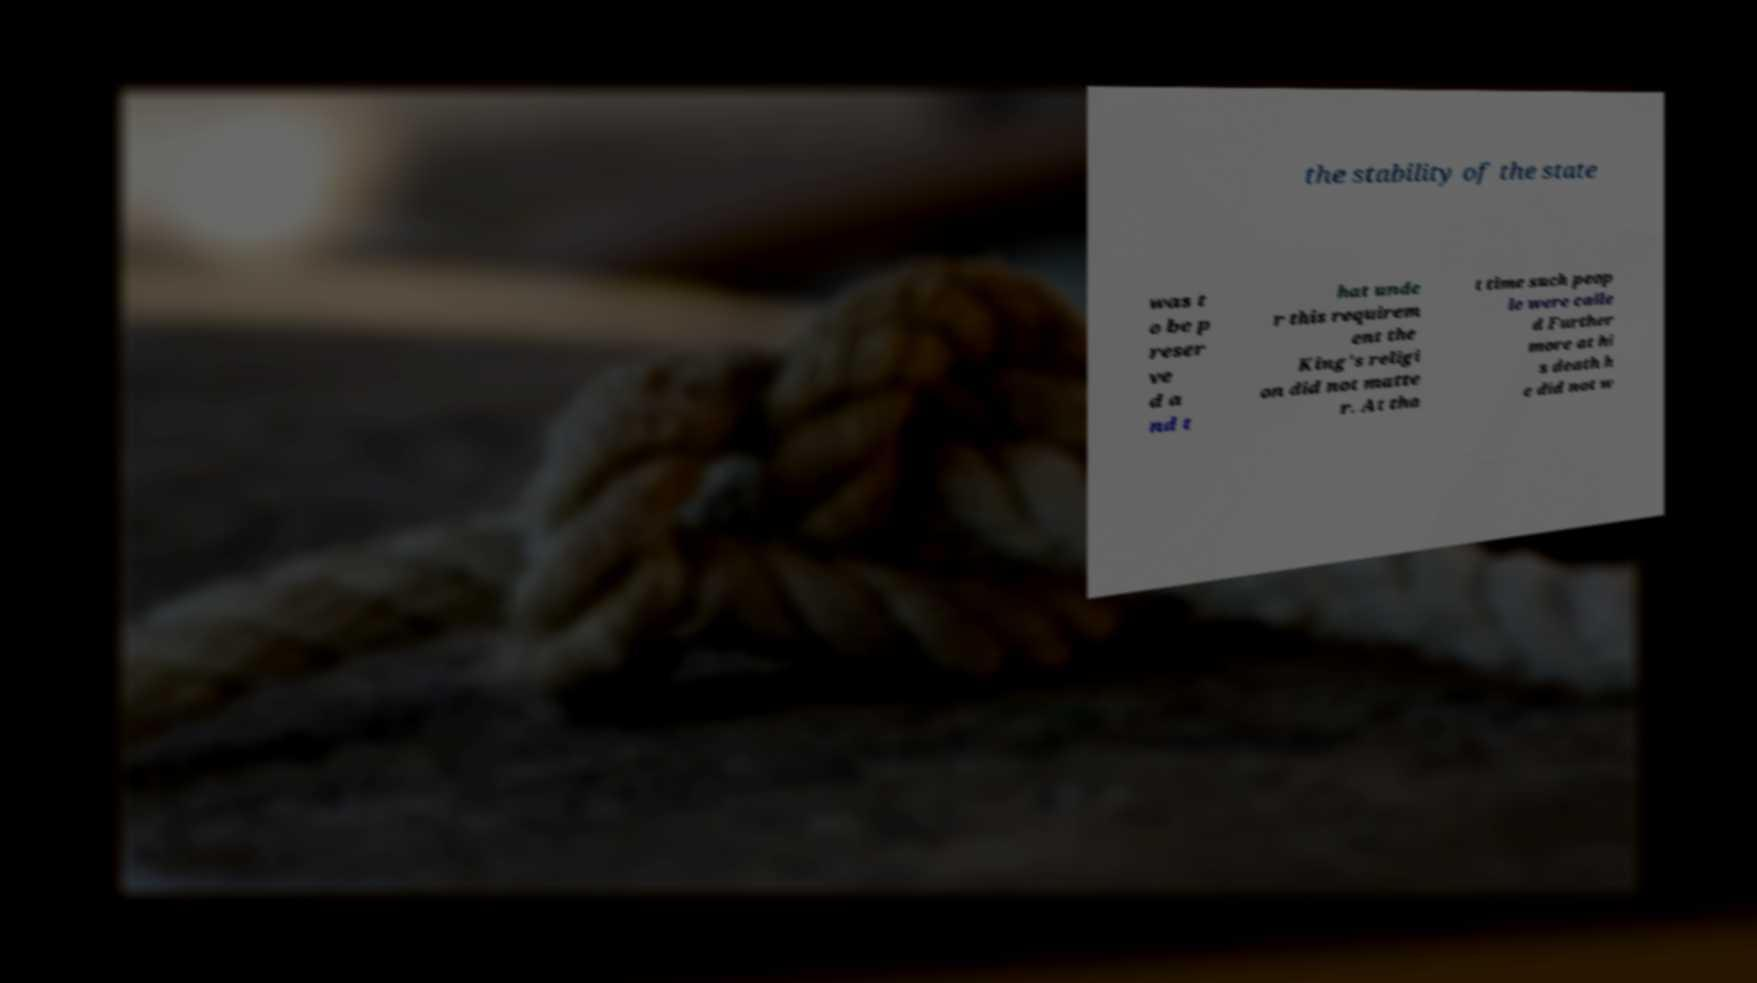There's text embedded in this image that I need extracted. Can you transcribe it verbatim? the stability of the state was t o be p reser ve d a nd t hat unde r this requirem ent the King's religi on did not matte r. At tha t time such peop le were calle d Further more at hi s death h e did not w 